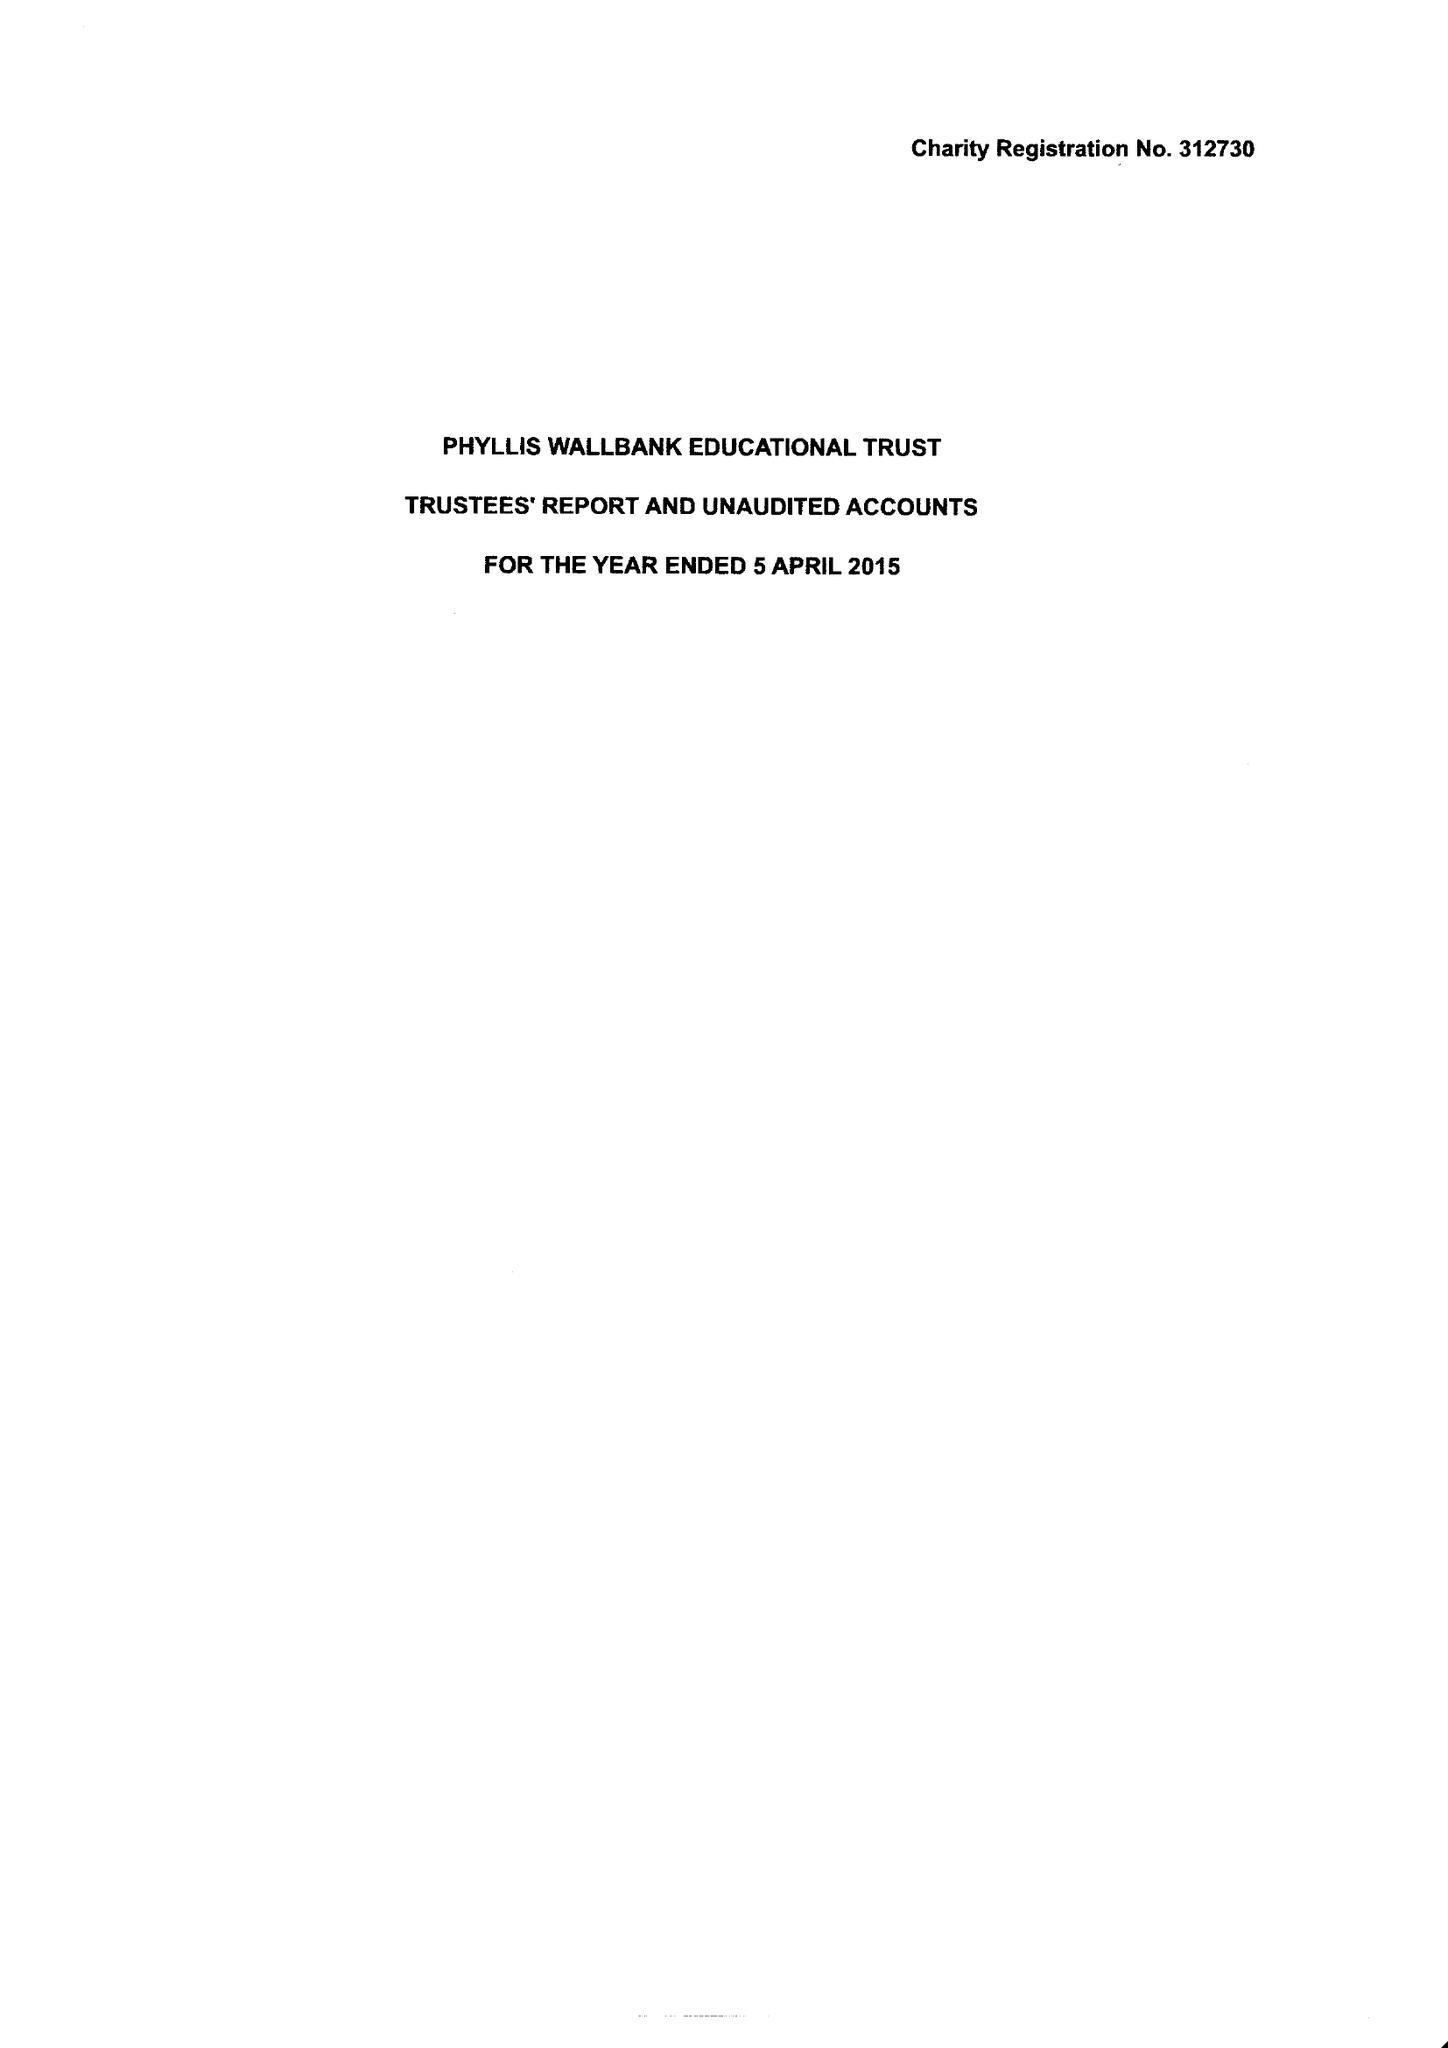What is the value for the charity_number?
Answer the question using a single word or phrase. 312730 